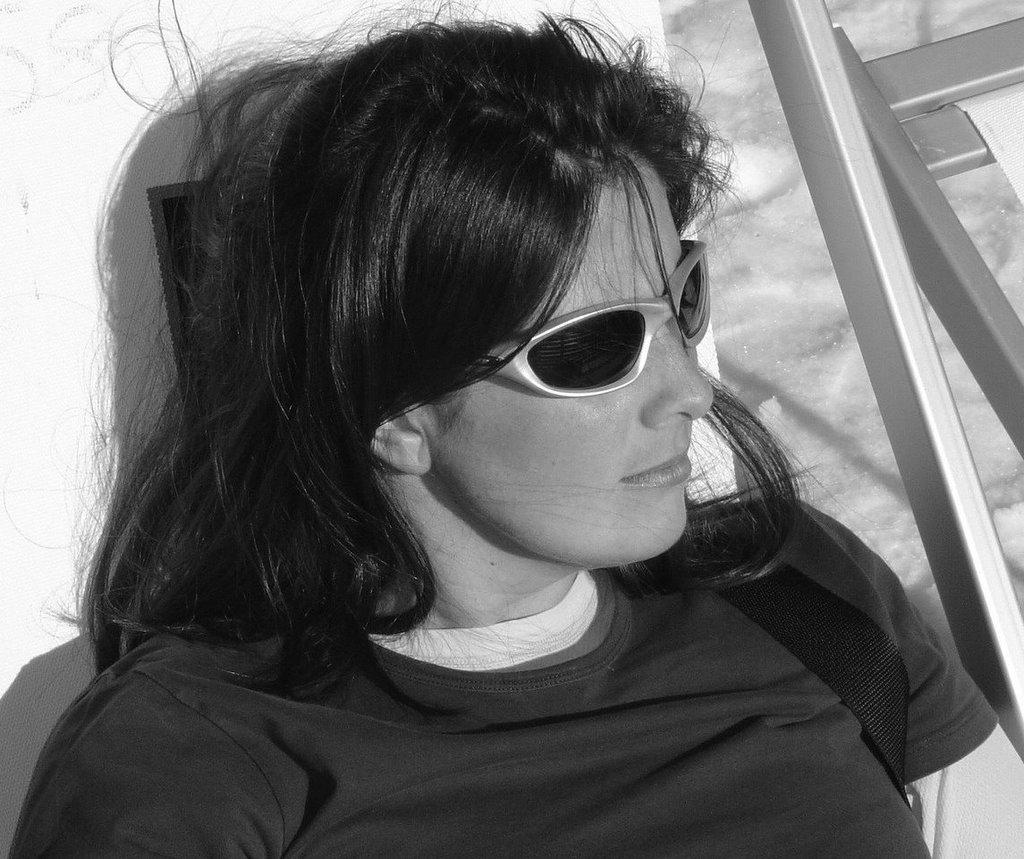Who is in the picture? There is a woman in the picture. What is the woman wearing on her face? The woman is wearing goggles. What color is the woman's t-shirt? The woman is wearing a black t-shirt. What is the woman sitting on? The woman is sitting on a bench. What is located beside the bench? There is a steel ladder beside the bench. How many dimes can be seen on the ground in the image? There is no mention of dimes or a ground in the image; it only features a woman, goggles, a black t-shirt, a bench, and a steel ladder. 